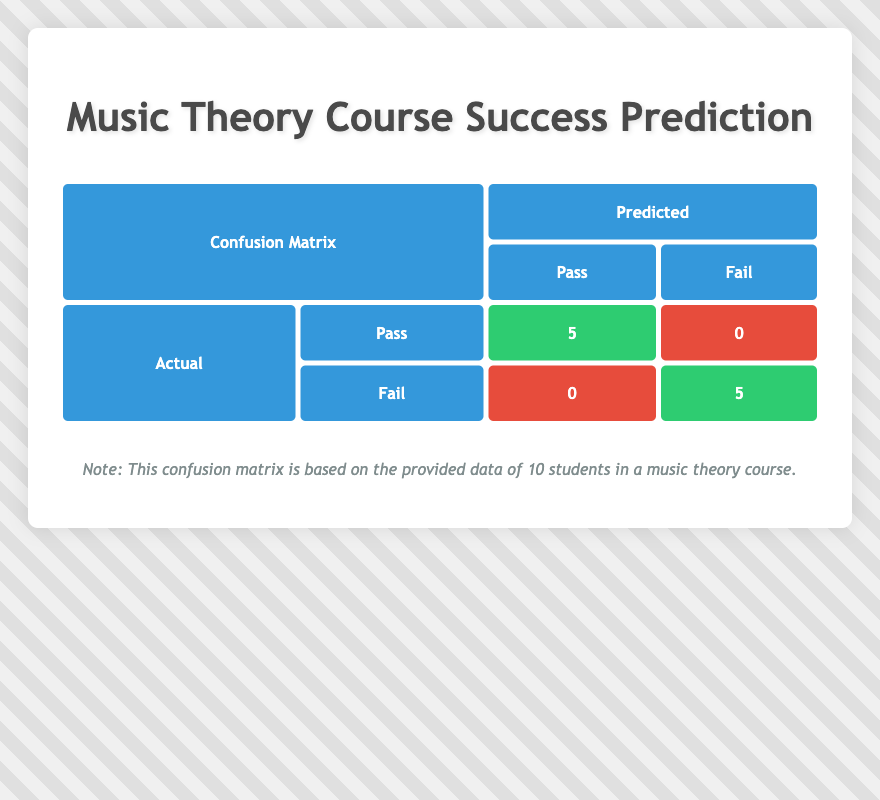What are the total number of true positives in the confusion matrix? The true positives are shown under the "Pass" category in the "Predicted" column and the "Actual" row. The value is 5.
Answer: 5 How many students failed the music theory course based on the data? The table indicates the true negatives under the "Fail" category in the "Predicted" column and the "Fail" row, which is 5.
Answer: 5 What is the total number of students who passed the course? To find the total number of students who passed, we can sum the true positives (5) and the false positives (0), resulting in 5 + 0 = 5.
Answer: 5 Is it true that all students with prior experience at the "Beginner" level failed the course? According to the data in the table, all "Beginner" students (3 students) have "Fail" entries under "Actual," confirming that the statement is true.
Answer: Yes What is the relationship between prior experience and success in the music theory course based on the table? The confusion matrix indicates that all students with "Intermediate" and "Advanced" experience passed the course (5 students in total), while all "Beginner" students failed. Therefore, higher prior experience correlates with success in the course.
Answer: Higher prior experience is linked to success 